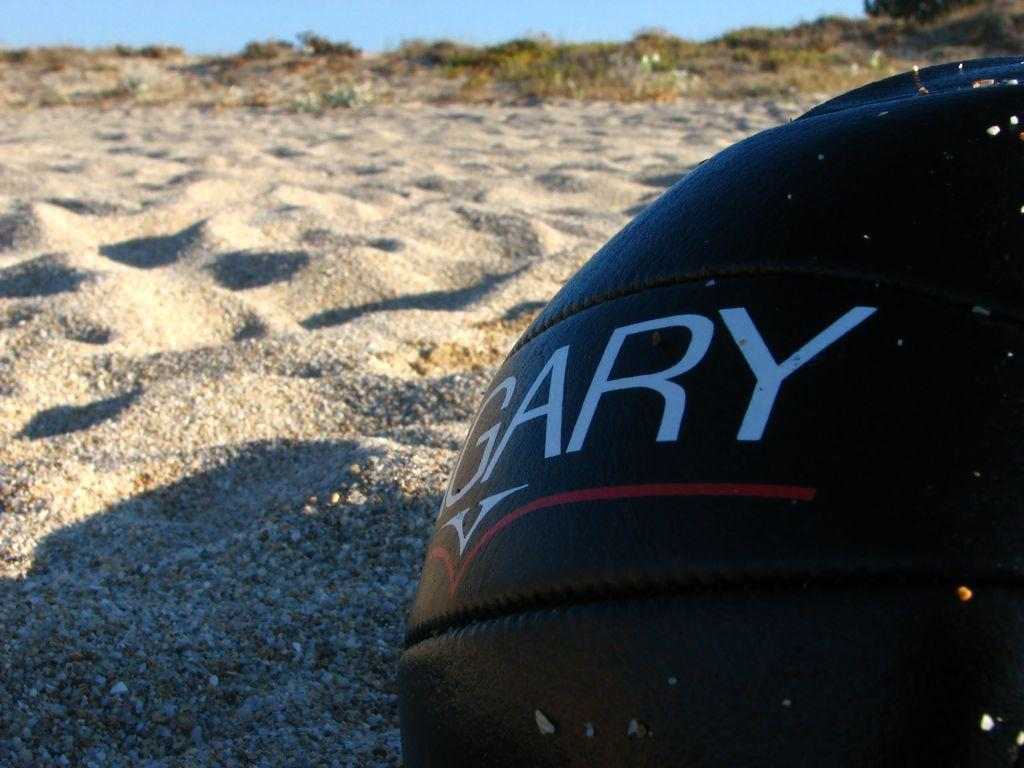What type of terrain is visible in the image? There is sand in the image. What can be seen on the right side of the image? There is an object on the right side of the image. What other natural elements are present in the image? There are plants in the image. What is visible at the top of the image? The top of the image appears to be either sky or water. What color is the sock that the toad is wearing in the image? There is no toad or sock present in the image. What type of alarm can be heard in the background of the image? There is no alarm present in the image, as it is a still image without any sound. 